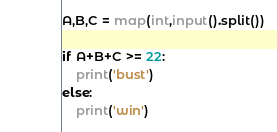<code> <loc_0><loc_0><loc_500><loc_500><_Python_>A,B,C = map(int,input().split())

if A+B+C >= 22:
    print('bust')
else:
    print('win')
</code> 